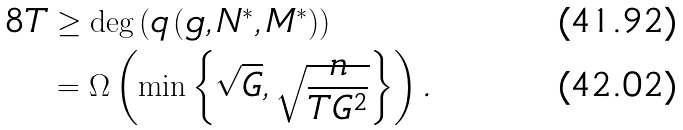Convert formula to latex. <formula><loc_0><loc_0><loc_500><loc_500>8 T & \geq \deg \left ( q \left ( g , N ^ { \ast } , M ^ { \ast } \right ) \right ) \\ & = \Omega \left ( \min \left \{ \sqrt { G } , \sqrt { \frac { n } { T G ^ { 2 } } } \right \} \right ) .</formula> 